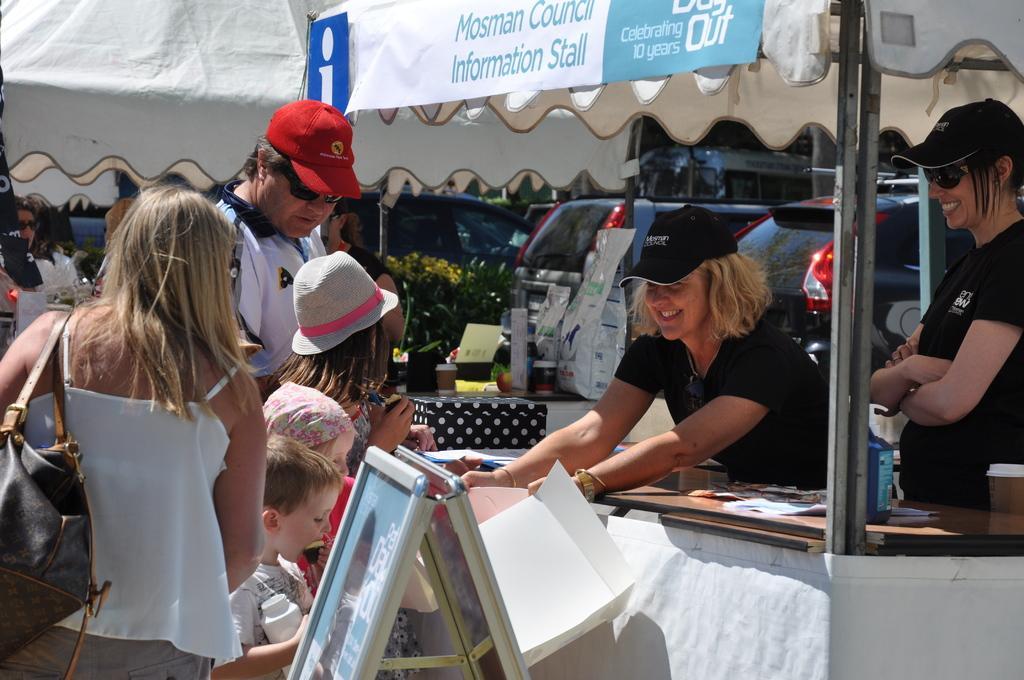In one or two sentences, can you explain what this image depicts? In this picture we can see a group of people, here we can see tents and some objects and in the background we can see vehicles and plants. 